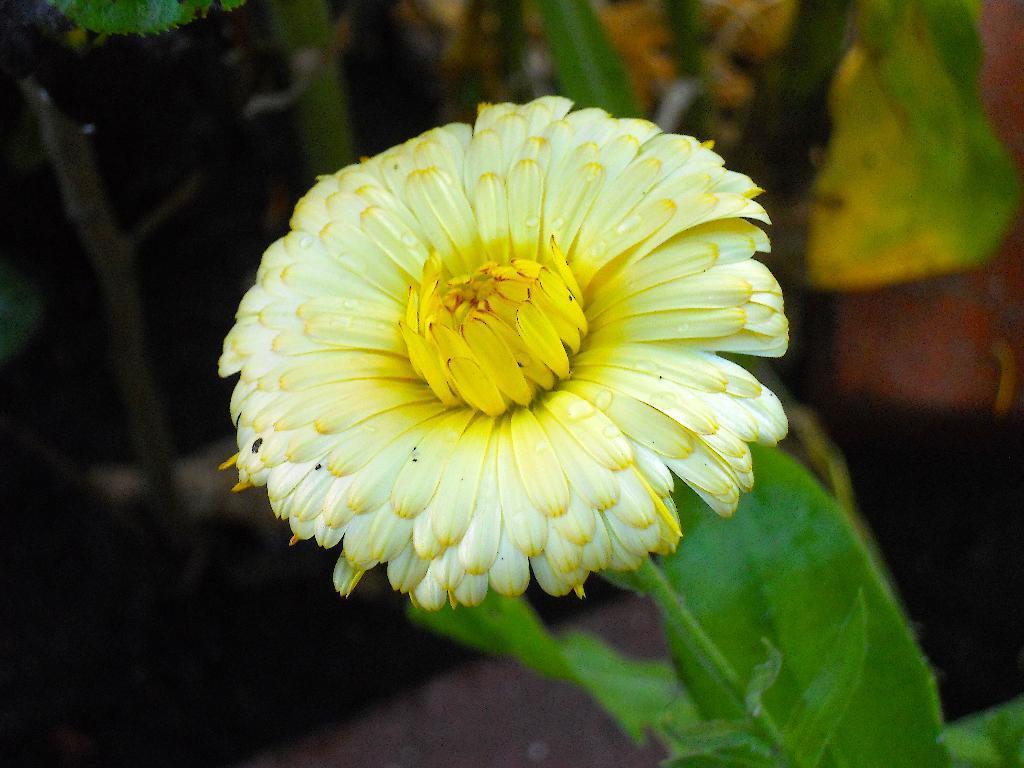Please provide a concise description of this image. In this image I can see a flower and leaf 